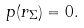Convert formula to latex. <formula><loc_0><loc_0><loc_500><loc_500>p ( r _ { \Sigma } ) = 0 .</formula> 